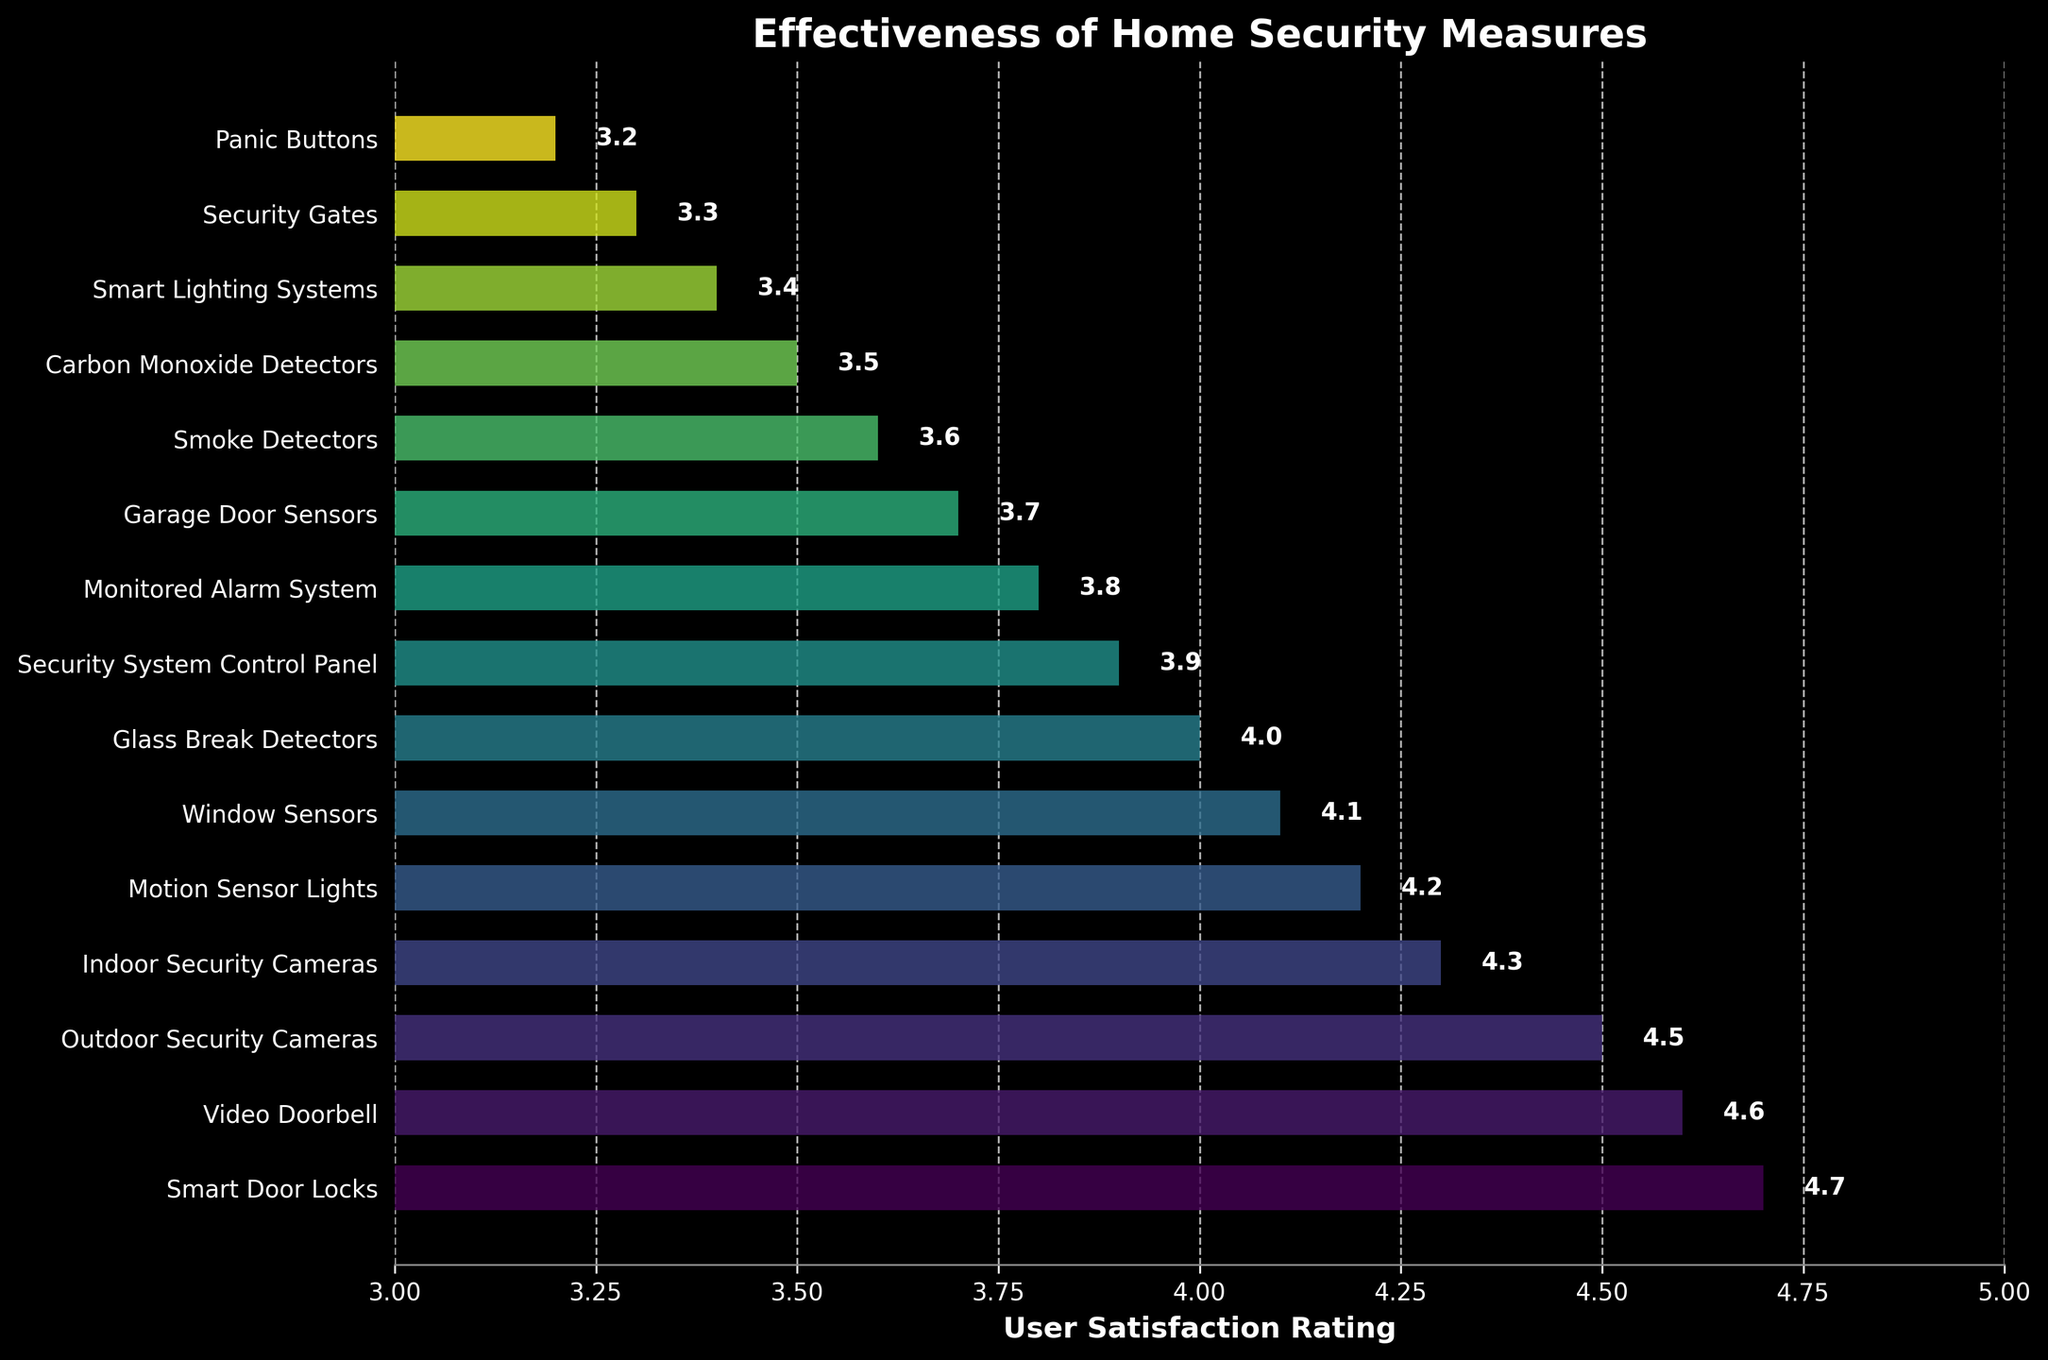What's the highest user satisfaction rating among the home security measures? First, locate the highest bar in the bar chart. The label next to the highest bar indicates the user satisfaction rating. The highest rating is 4.7 for Smart Door Locks.
Answer: 4.7 Which home security measure has the lowest user satisfaction rating? Identify the shortest bar in the chart. The label next to this bar indicates the home security measure with the lowest rating. It is Panic Buttons with a rating of 3.2.
Answer: Panic Buttons How many security measures have a user satisfaction rating greater than 4.0? Count the number of bars that extend beyond the 4.0 mark on the x-axis. These bars represent the security measures with a rating greater than 4.0. There are 5 such measures.
Answer: 5 Which security measure is rated higher: Window Sensors or Glass Break Detectors? Compare the length of the bars for Window Sensors and Glass Break Detectors. Window Sensors has a higher rating (4.1) than Glass Break Detectors (4.0).
Answer: Window Sensors What is the mean user satisfaction rating for Smart Door Locks and Video Doorbells? Sum the user satisfaction ratings for Smart Door Locks (4.7) and Video Doorbells (4.6) and divide by 2. (4.7 + 4.6) / 2 = 4.65
Answer: 4.65 What is the combined user satisfaction rating for Security Gates and Panic Buttons? Add the user satisfaction ratings for Security Gates (3.3) and Panic Buttons (3.2). 3.3 + 3.2 = 6.5
Answer: 6.5 Which has a higher user satisfaction: Smoke Detectors or Carbon Monoxide Detectors, and by how much? Compare the ratings for Smoke Detectors (3.6) and Carbon Monoxide Detectors (3.5). Subtract the lower rating from the higher rating to find the difference. 3.6 - 3.5 = 0.1
Answer: Smoke Detectors, by 0.1 By how much is the satisfaction rating of Outdoor Security Cameras higher than that of Garage Door Sensors? Subtract the rating of Garage Door Sensors (3.7) from the rating of Outdoor Security Cameras (4.5). 4.5 - 3.7 = 0.8
Answer: 0.8 Which security measure is rated just below Motion Sensor Lights? Look at the bar right below Motion Sensor Lights in the chart to find the immediately lesser rating. It is Window Sensors with a rating of 4.1.
Answer: Window Sensors 